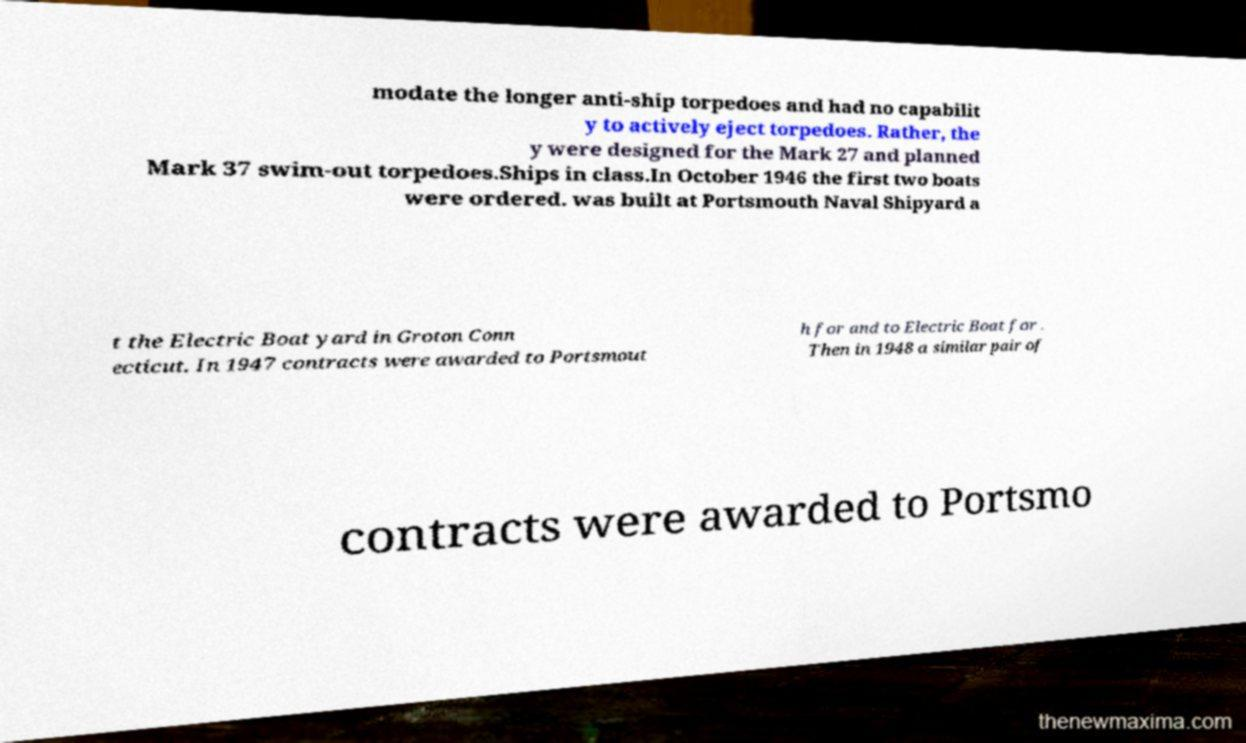There's text embedded in this image that I need extracted. Can you transcribe it verbatim? modate the longer anti-ship torpedoes and had no capabilit y to actively eject torpedoes. Rather, the y were designed for the Mark 27 and planned Mark 37 swim-out torpedoes.Ships in class.In October 1946 the first two boats were ordered. was built at Portsmouth Naval Shipyard a t the Electric Boat yard in Groton Conn ecticut. In 1947 contracts were awarded to Portsmout h for and to Electric Boat for . Then in 1948 a similar pair of contracts were awarded to Portsmo 